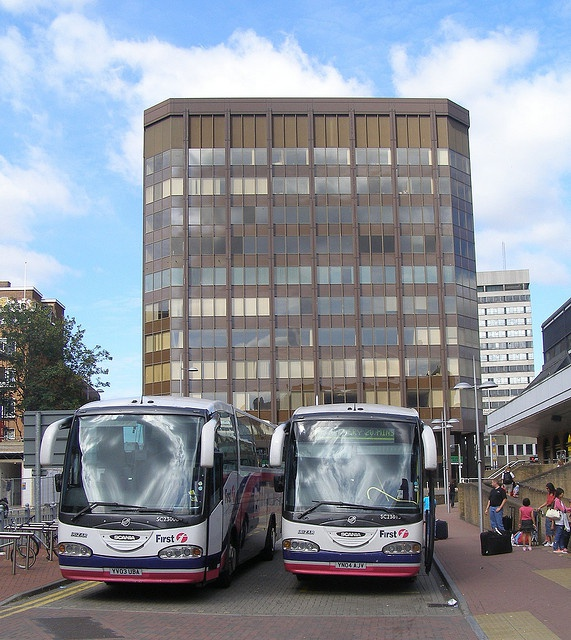Describe the objects in this image and their specific colors. I can see bus in lavender, black, gray, darkgray, and lightgray tones, bus in lavender, darkgray, gray, black, and lightgray tones, people in lavender, black, gray, darkgray, and navy tones, suitcase in lavender, black, gray, and darkgray tones, and people in lavender, black, gray, and darkblue tones in this image. 